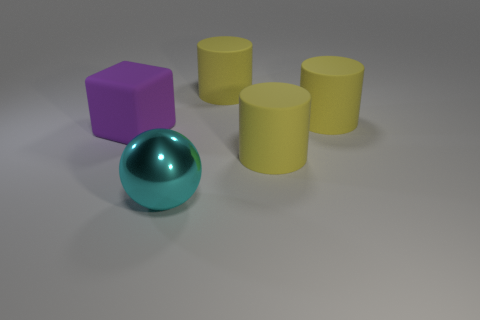Add 4 large yellow cylinders. How many objects exist? 9 Subtract all cylinders. How many objects are left? 2 Subtract all big matte things. Subtract all cyan things. How many objects are left? 0 Add 3 large cyan objects. How many large cyan objects are left? 4 Add 2 large red matte things. How many large red matte things exist? 2 Subtract 0 yellow blocks. How many objects are left? 5 